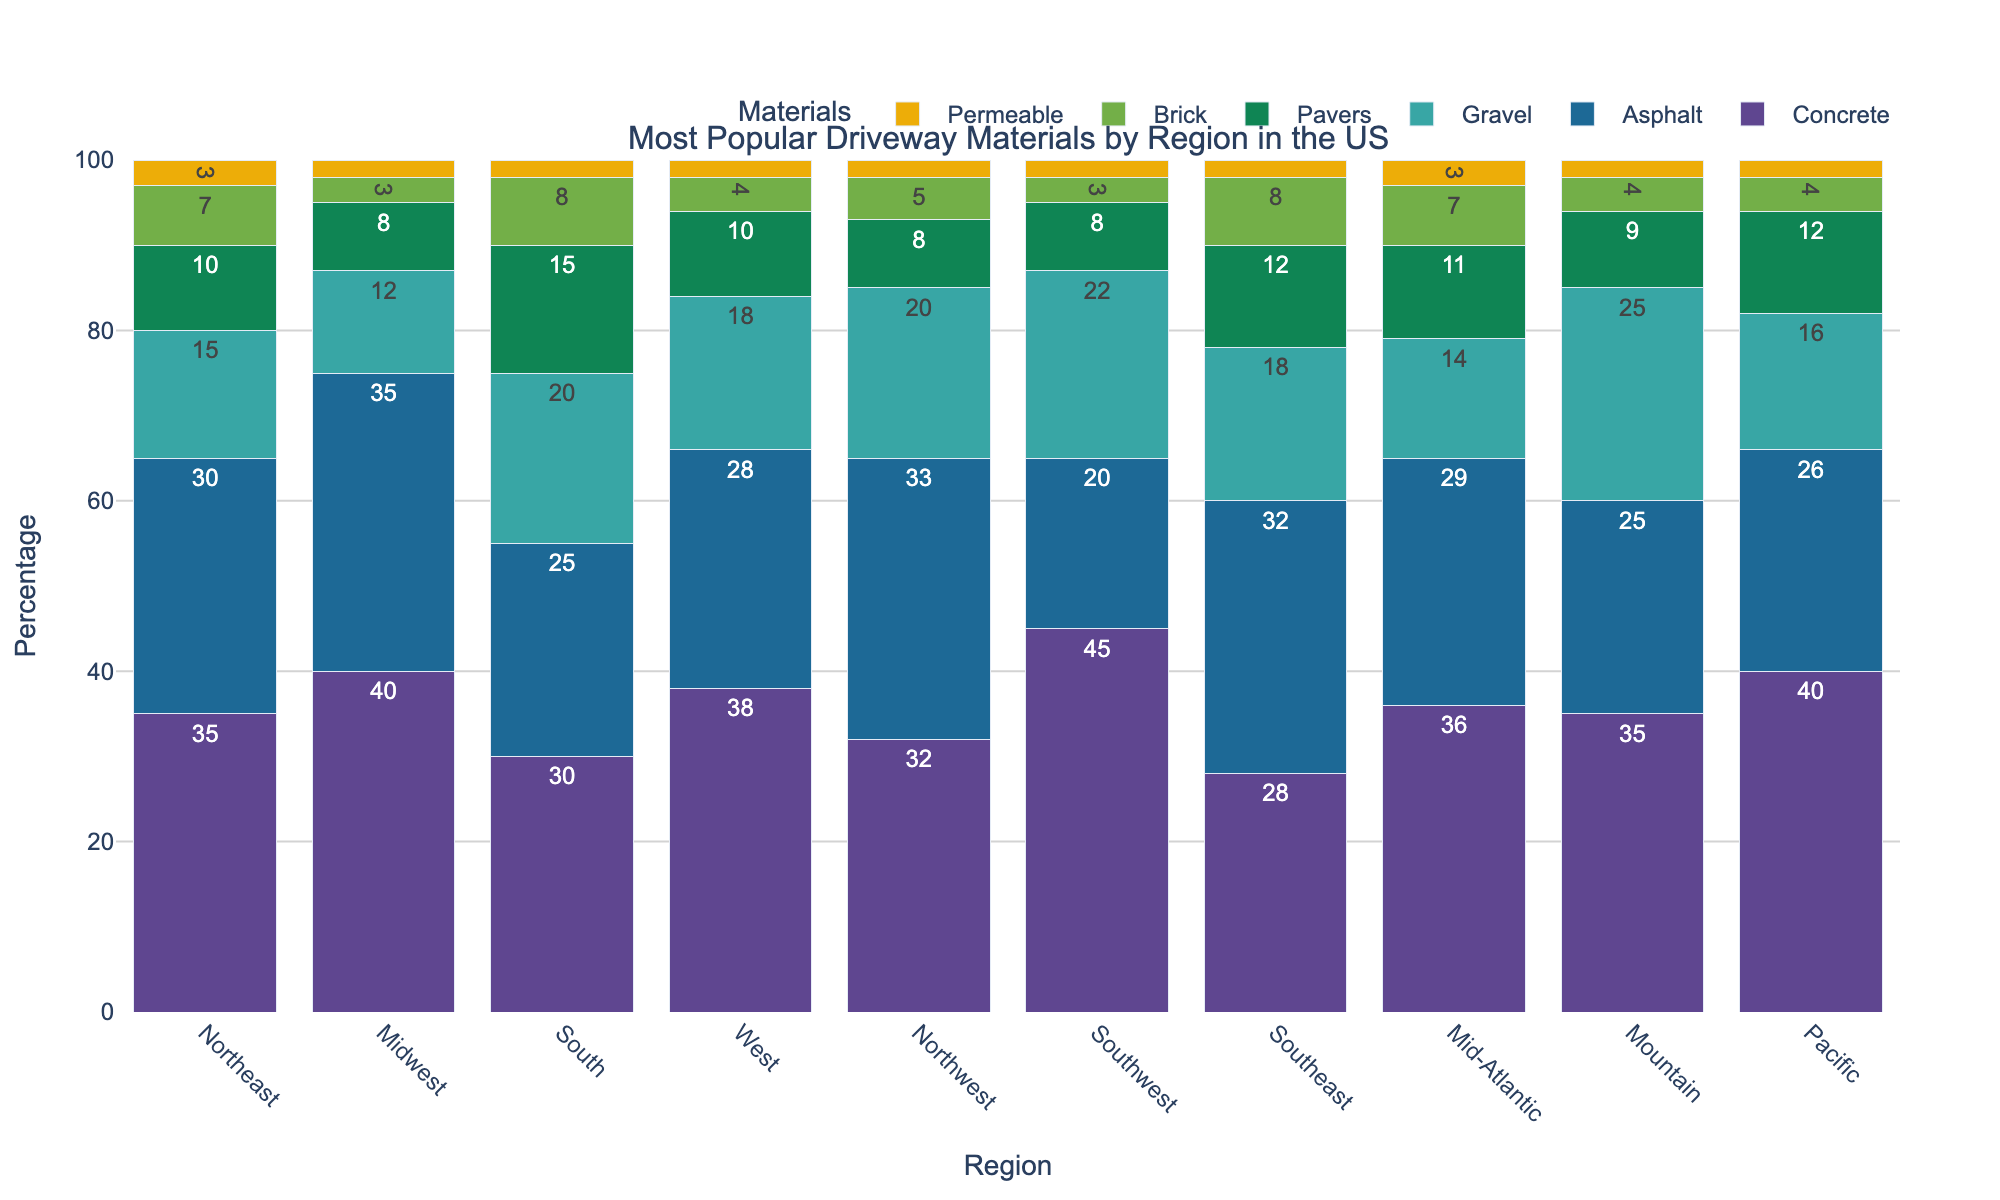Which region has the highest percentage of concrete driveways? The tallest bar for concrete driveways represents the region with the highest percentage. In this case, Southwest has the highest bar for concrete at 45%.
Answer: Southwest Which material is the least popular in the Northeast? By looking at the shortest bar in the Northeast stack, permeable driveways are the least popular with a percentage of 3%.
Answer: Permeable Does any region have an equal percentage of asphalt and pavers? By comparing the heights of the bars, the Southwest region shows both asphalt and pavers at around 8% (although asphalt slightly less).
Answer: No What is the median percentage of gravel driveways across all regions? Sort the percentages of gravel driveways: 12, 14, 15, 16, 18, 18, 20, 20, 22, 25. The median is the middle value which is (18+18)/2 since the sorted list has an even number of entries. This calculates to 18.
Answer: 18 In the Midwest, which material is more popular: brick or pavers? Visually comparing the height of the bars for brick and pavers in the Midwest stack, brick has a percentage of 3% while pavers have 8%.
Answer: Pavers How does the percentage of permeable driveways in the Southeast compare to the Mountain region? Compare the bars directly; both the Southeast and Mountain regions have permeable driveways at 2%.
Answer: They are equal What's the sum of the percentages for brick and concrete driveways in the West region? Add the percentages for concrete (38%) and brick (4%) in the West region. So, 38 + 4 = 42%.
Answer: 42% Which region shows the most evenly distributed preference across the materials? Look for the region with bars closest in height to each other. The Mountain region's bars (35%, 25%, 25%, 9%, 4%, 2%) are closer in height compared to others.
Answer: Mountain What visual pattern can you observe in the preference for concrete across different regions? The concrete bars are consistently one of the tallest in each region, indicating that concrete is the most or second most popular material in nearly every region.
Answer: Consistently high Is the gravel driveway percentage in the South higher or lower than that in the Northeast? By comparing the heights of the gravel bars, the South shows 20% while the Northeast shows 15%, making the percentage in the South higher.
Answer: Higher 